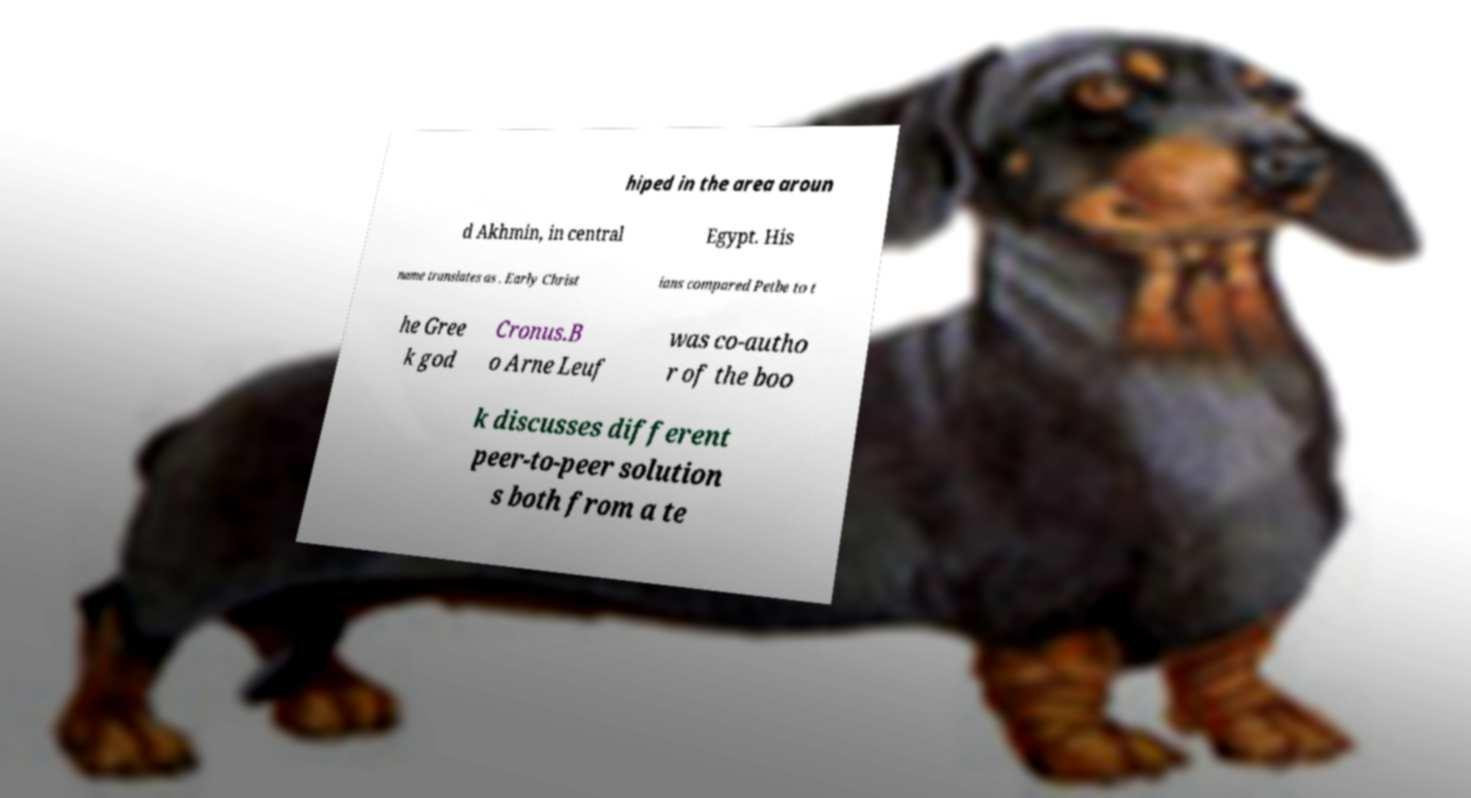There's text embedded in this image that I need extracted. Can you transcribe it verbatim? hiped in the area aroun d Akhmin, in central Egypt. His name translates as . Early Christ ians compared Petbe to t he Gree k god Cronus.B o Arne Leuf was co-autho r of the boo k discusses different peer-to-peer solution s both from a te 